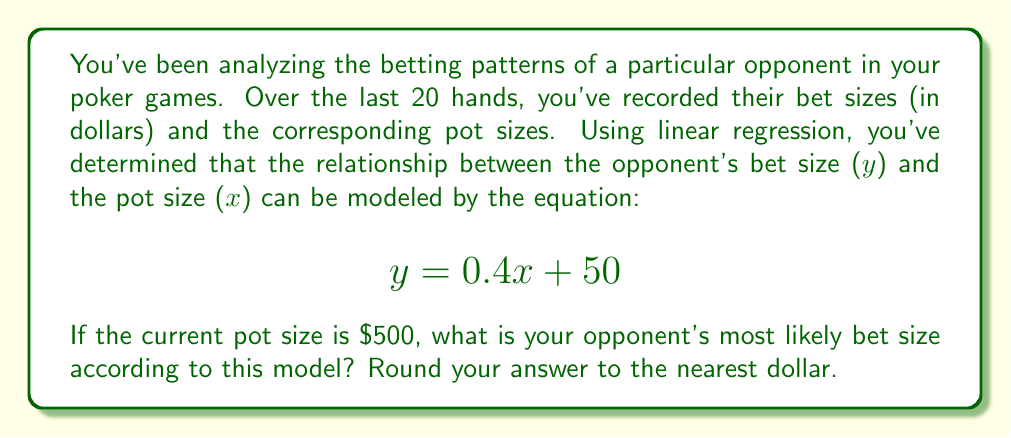Can you solve this math problem? To solve this problem, we'll follow these steps:

1) We have the linear regression model:
   $$y = 0.4x + 50$$
   where $y$ is the predicted bet size and $x$ is the pot size.

2) We're given that the current pot size ($x$) is $500.

3) To find the predicted bet size, we simply need to substitute $x = 500$ into our equation:

   $$y = 0.4(500) + 50$$

4) Let's calculate this step-by-step:
   $$y = 200 + 50$$
   $$y = 250$$

5) The question asks for the answer rounded to the nearest dollar, but 250 is already a whole number, so no rounding is necessary.

This prediction suggests that, based on the opponent's past betting patterns, they are most likely to bet $250 when the pot size is $500.
Answer: $250 